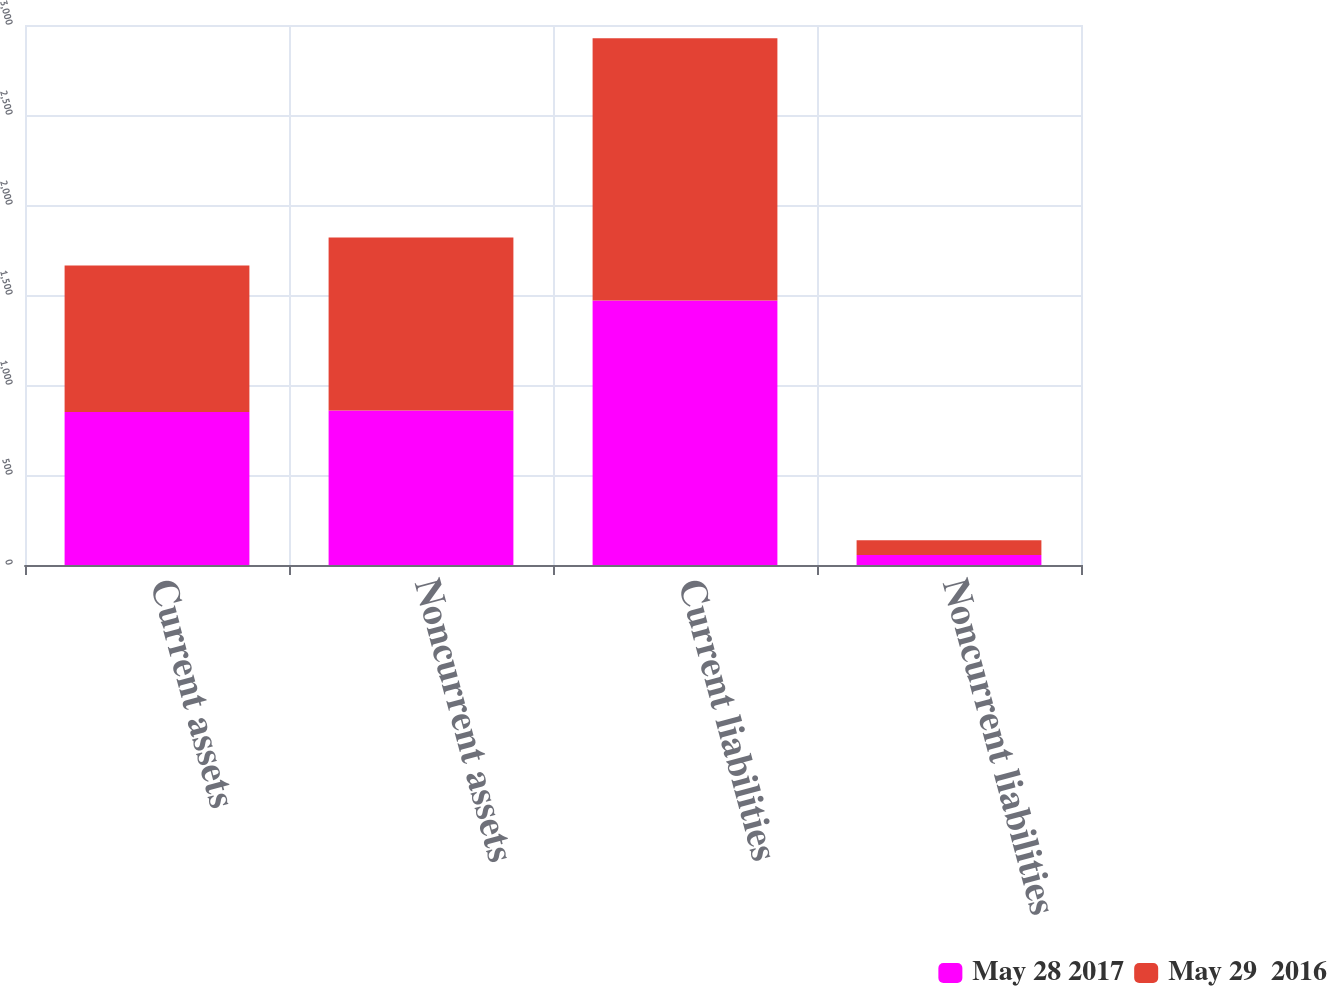Convert chart. <chart><loc_0><loc_0><loc_500><loc_500><stacked_bar_chart><ecel><fcel>Current assets<fcel>Noncurrent assets<fcel>Current liabilities<fcel>Noncurrent liabilities<nl><fcel>May 28 2017<fcel>849.7<fcel>858.9<fcel>1469.6<fcel>55.2<nl><fcel>May 29  2016<fcel>814.1<fcel>959.9<fcel>1457.3<fcel>81.7<nl></chart> 